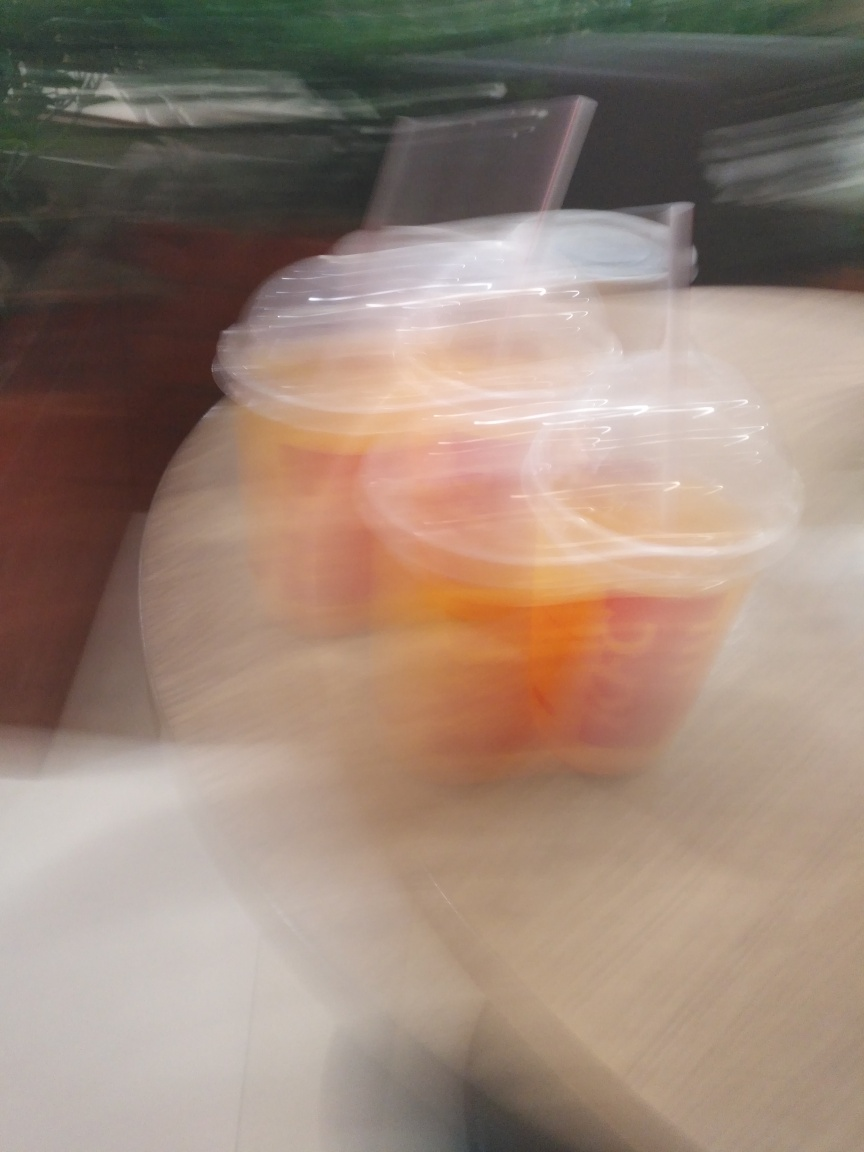Can the quality of a photo like this be improved after it's been taken? Improving the quality of a photo with such significant motion blur would be challenging. Some advanced editing software can reduce blur to an extent, but it cannot completely restore lost detail. It's usually best to prevent blur by using appropriate camera settings and stabilization techniques when taking the photo. What tips can you offer for taking a clearer photo in similar conditions? To take a clearer photo in similar conditions, one could use a faster shutter speed to freeze motion, stabilize the camera using a tripod or steady surface, and increase the ISO setting to compensate for reduced exposure time if the lighting is low. Additionally, using a flash can help illuminate the subject and reduce blur caused by movement. 